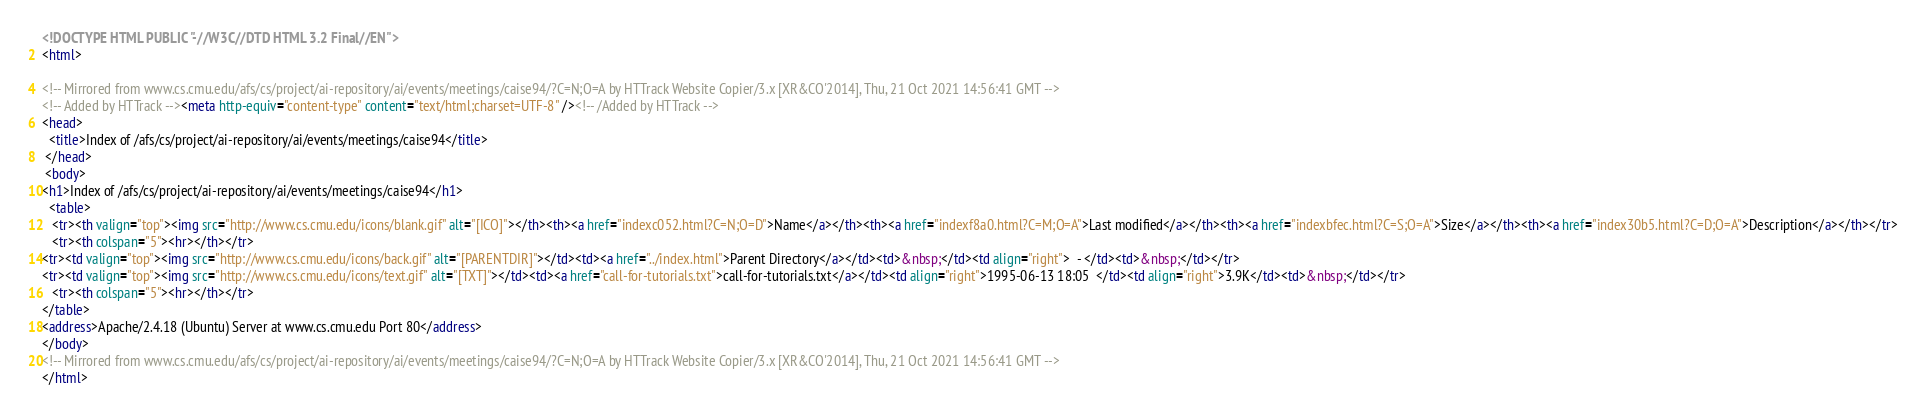Convert code to text. <code><loc_0><loc_0><loc_500><loc_500><_HTML_><!DOCTYPE HTML PUBLIC "-//W3C//DTD HTML 3.2 Final//EN">
<html>
 
<!-- Mirrored from www.cs.cmu.edu/afs/cs/project/ai-repository/ai/events/meetings/caise94/?C=N;O=A by HTTrack Website Copier/3.x [XR&CO'2014], Thu, 21 Oct 2021 14:56:41 GMT -->
<!-- Added by HTTrack --><meta http-equiv="content-type" content="text/html;charset=UTF-8" /><!-- /Added by HTTrack -->
<head>
  <title>Index of /afs/cs/project/ai-repository/ai/events/meetings/caise94</title>
 </head>
 <body>
<h1>Index of /afs/cs/project/ai-repository/ai/events/meetings/caise94</h1>
  <table>
   <tr><th valign="top"><img src="http://www.cs.cmu.edu/icons/blank.gif" alt="[ICO]"></th><th><a href="indexc052.html?C=N;O=D">Name</a></th><th><a href="indexf8a0.html?C=M;O=A">Last modified</a></th><th><a href="indexbfec.html?C=S;O=A">Size</a></th><th><a href="index30b5.html?C=D;O=A">Description</a></th></tr>
   <tr><th colspan="5"><hr></th></tr>
<tr><td valign="top"><img src="http://www.cs.cmu.edu/icons/back.gif" alt="[PARENTDIR]"></td><td><a href="../index.html">Parent Directory</a></td><td>&nbsp;</td><td align="right">  - </td><td>&nbsp;</td></tr>
<tr><td valign="top"><img src="http://www.cs.cmu.edu/icons/text.gif" alt="[TXT]"></td><td><a href="call-for-tutorials.txt">call-for-tutorials.txt</a></td><td align="right">1995-06-13 18:05  </td><td align="right">3.9K</td><td>&nbsp;</td></tr>
   <tr><th colspan="5"><hr></th></tr>
</table>
<address>Apache/2.4.18 (Ubuntu) Server at www.cs.cmu.edu Port 80</address>
</body>
<!-- Mirrored from www.cs.cmu.edu/afs/cs/project/ai-repository/ai/events/meetings/caise94/?C=N;O=A by HTTrack Website Copier/3.x [XR&CO'2014], Thu, 21 Oct 2021 14:56:41 GMT -->
</html>
</code> 